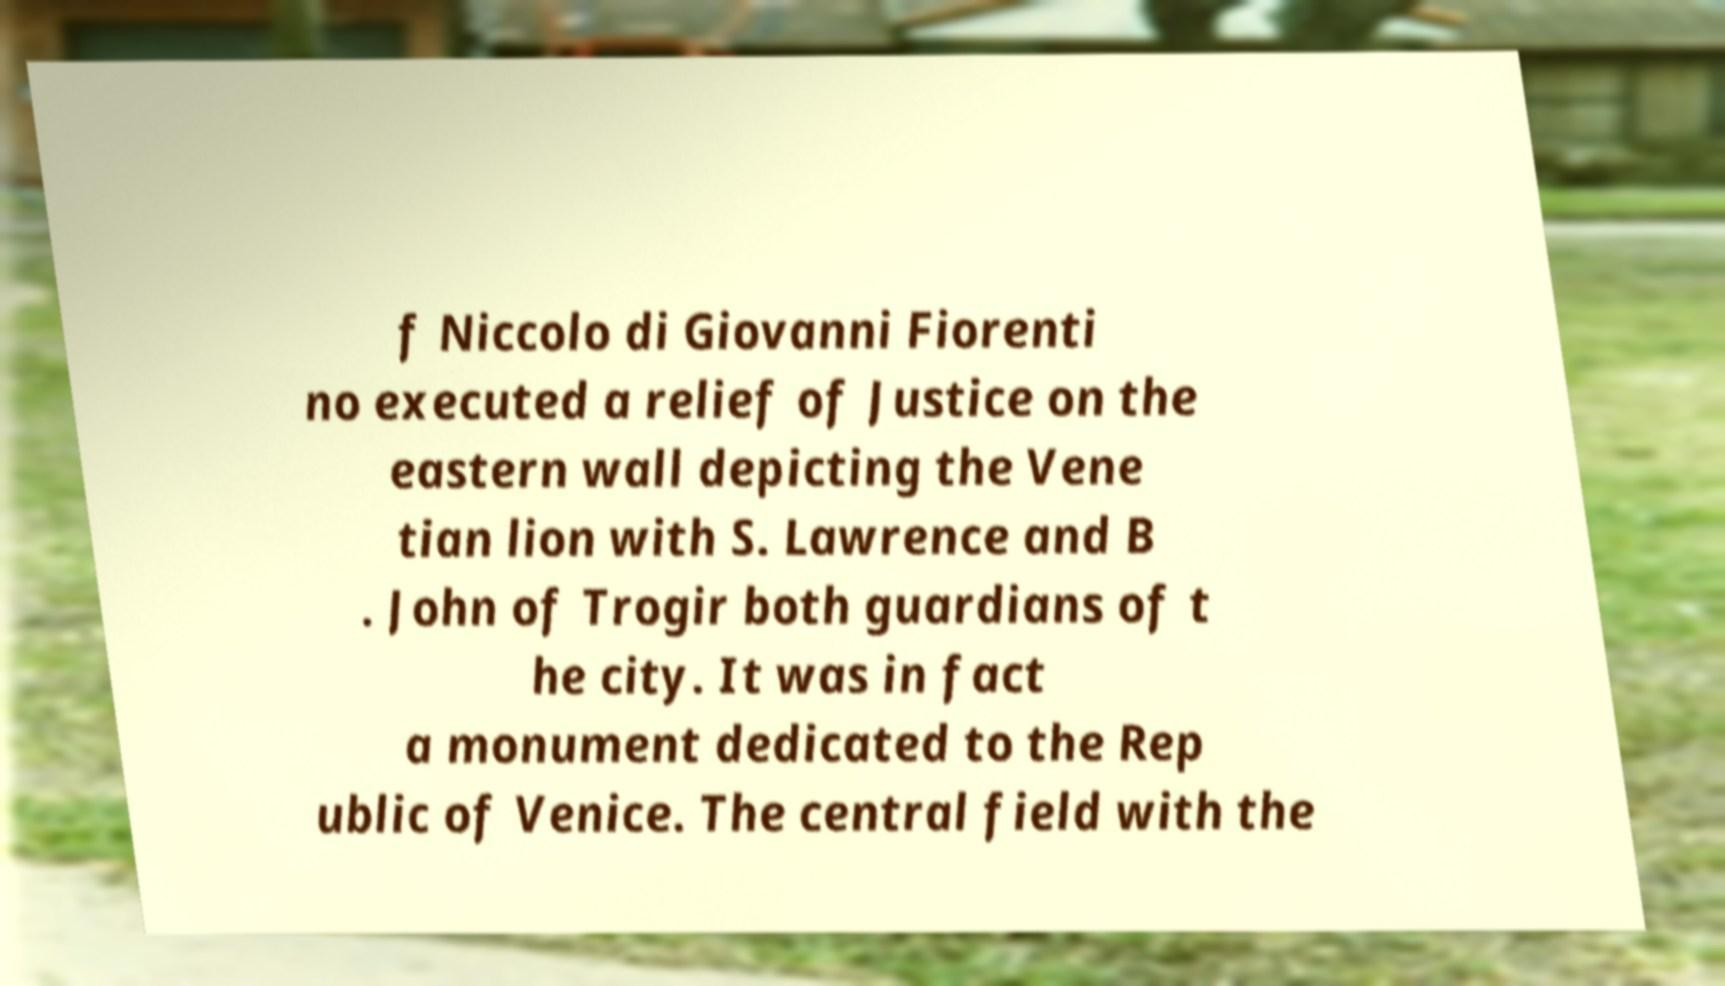Can you accurately transcribe the text from the provided image for me? f Niccolo di Giovanni Fiorenti no executed a relief of Justice on the eastern wall depicting the Vene tian lion with S. Lawrence and B . John of Trogir both guardians of t he city. It was in fact a monument dedicated to the Rep ublic of Venice. The central field with the 